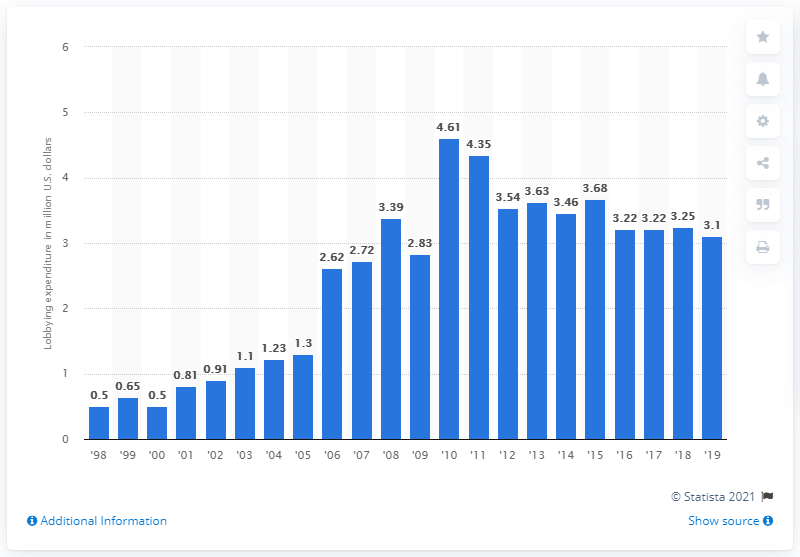Identify some key points in this picture. The lobbying expenditure at Goldman Sachs in 2019 was 3.1 million dollars. 